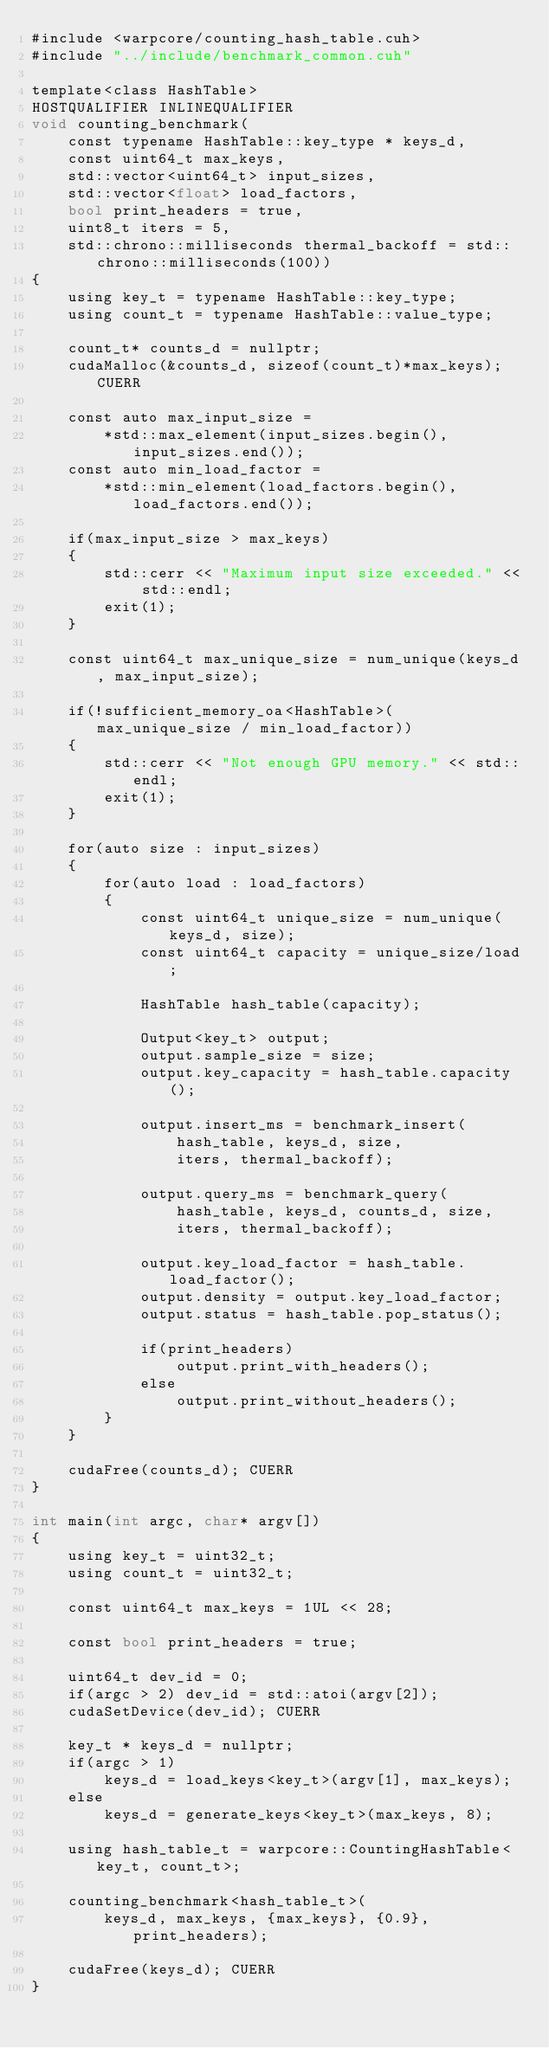<code> <loc_0><loc_0><loc_500><loc_500><_Cuda_>#include <warpcore/counting_hash_table.cuh>
#include "../include/benchmark_common.cuh"

template<class HashTable>
HOSTQUALIFIER INLINEQUALIFIER
void counting_benchmark(
    const typename HashTable::key_type * keys_d,
    const uint64_t max_keys,
    std::vector<uint64_t> input_sizes,
    std::vector<float> load_factors,
    bool print_headers = true,
    uint8_t iters = 5,
    std::chrono::milliseconds thermal_backoff = std::chrono::milliseconds(100))
{
    using key_t = typename HashTable::key_type;
    using count_t = typename HashTable::value_type;

    count_t* counts_d = nullptr;
    cudaMalloc(&counts_d, sizeof(count_t)*max_keys); CUERR

    const auto max_input_size =
        *std::max_element(input_sizes.begin(), input_sizes.end());
    const auto min_load_factor =
        *std::min_element(load_factors.begin(), load_factors.end());

    if(max_input_size > max_keys)
    {
        std::cerr << "Maximum input size exceeded." << std::endl;
        exit(1);
    }

    const uint64_t max_unique_size = num_unique(keys_d, max_input_size);

    if(!sufficient_memory_oa<HashTable>(max_unique_size / min_load_factor))
    {
        std::cerr << "Not enough GPU memory." << std::endl;
        exit(1);
    }

    for(auto size : input_sizes)
    {
        for(auto load : load_factors)
        {
            const uint64_t unique_size = num_unique(keys_d, size);
            const uint64_t capacity = unique_size/load;

            HashTable hash_table(capacity);

            Output<key_t> output;
            output.sample_size = size;
            output.key_capacity = hash_table.capacity();

            output.insert_ms = benchmark_insert(
                hash_table, keys_d, size,
                iters, thermal_backoff);

            output.query_ms = benchmark_query(
                hash_table, keys_d, counts_d, size,
                iters, thermal_backoff);

            output.key_load_factor = hash_table.load_factor();
            output.density = output.key_load_factor;
            output.status = hash_table.pop_status();

            if(print_headers)
                output.print_with_headers();
            else
                output.print_without_headers();
        }
    }

    cudaFree(counts_d); CUERR
}

int main(int argc, char* argv[])
{
    using key_t = uint32_t;
    using count_t = uint32_t;

    const uint64_t max_keys = 1UL << 28;

    const bool print_headers = true;

    uint64_t dev_id = 0;
    if(argc > 2) dev_id = std::atoi(argv[2]);
    cudaSetDevice(dev_id); CUERR

    key_t * keys_d = nullptr;
    if(argc > 1)
        keys_d = load_keys<key_t>(argv[1], max_keys);
    else
        keys_d = generate_keys<key_t>(max_keys, 8);

    using hash_table_t = warpcore::CountingHashTable<key_t, count_t>;

    counting_benchmark<hash_table_t>(
        keys_d, max_keys, {max_keys}, {0.9}, print_headers);

    cudaFree(keys_d); CUERR
}</code> 